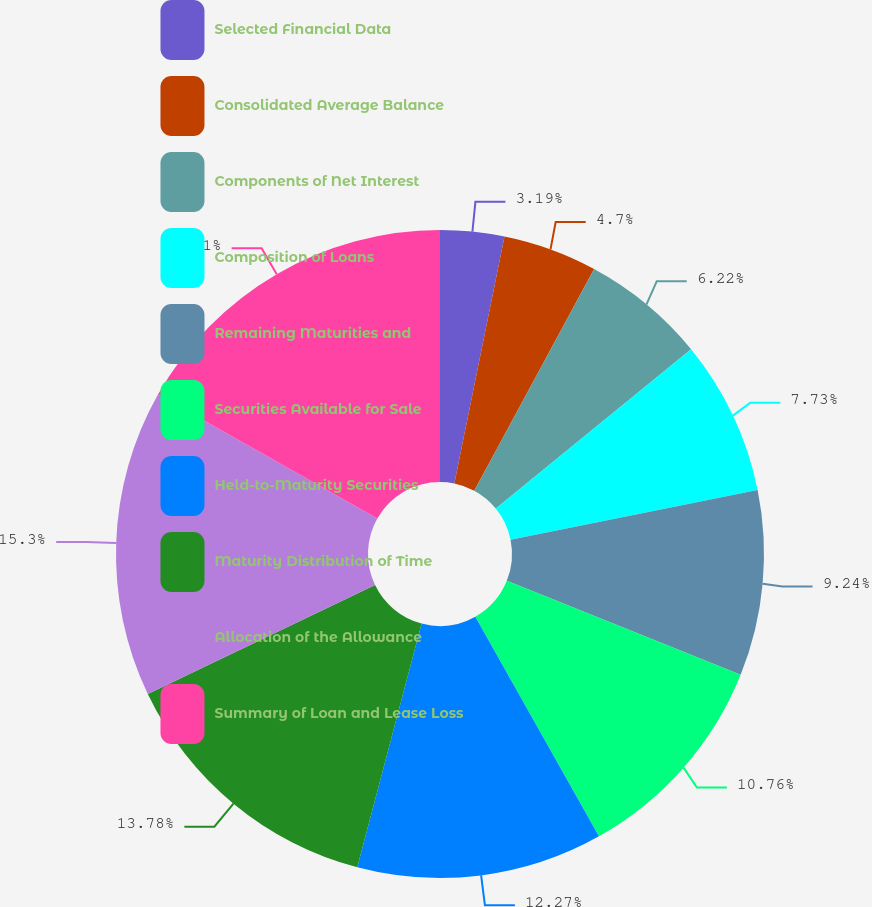Convert chart to OTSL. <chart><loc_0><loc_0><loc_500><loc_500><pie_chart><fcel>Selected Financial Data<fcel>Consolidated Average Balance<fcel>Components of Net Interest<fcel>Composition of Loans<fcel>Remaining Maturities and<fcel>Securities Available for Sale<fcel>Held-to-Maturity Securities<fcel>Maturity Distribution of Time<fcel>Allocation of the Allowance<fcel>Summary of Loan and Lease Loss<nl><fcel>3.19%<fcel>4.7%<fcel>6.22%<fcel>7.73%<fcel>9.24%<fcel>10.76%<fcel>12.27%<fcel>13.78%<fcel>15.3%<fcel>16.81%<nl></chart> 